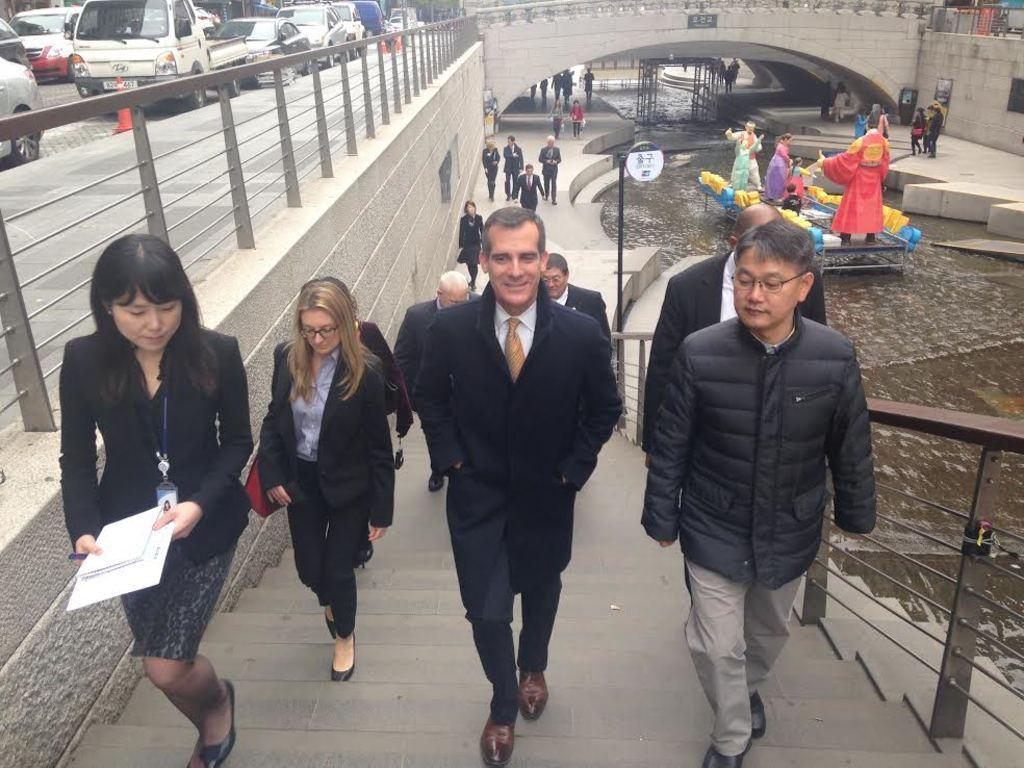Describe this image in one or two sentences. In the center of the image we can see people climbing steps. On the right there is a canal and we can see a boat in the canal. There are clowns in the boat. On the right there are cars. In the background we can see people, bridge and pillars. 